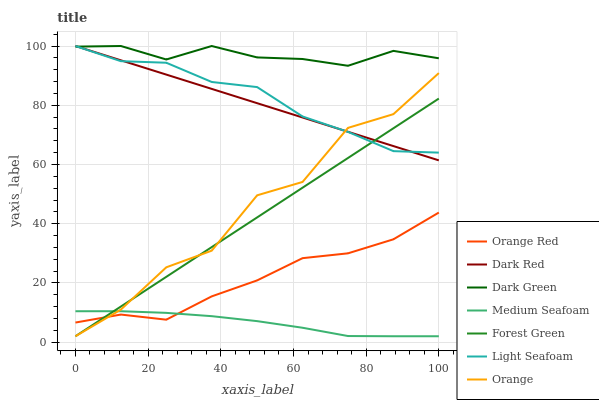Does Medium Seafoam have the minimum area under the curve?
Answer yes or no. Yes. Does Dark Green have the maximum area under the curve?
Answer yes or no. Yes. Does Orange Red have the minimum area under the curve?
Answer yes or no. No. Does Orange Red have the maximum area under the curve?
Answer yes or no. No. Is Dark Red the smoothest?
Answer yes or no. Yes. Is Orange the roughest?
Answer yes or no. Yes. Is Orange Red the smoothest?
Answer yes or no. No. Is Orange Red the roughest?
Answer yes or no. No. Does Forest Green have the lowest value?
Answer yes or no. Yes. Does Orange Red have the lowest value?
Answer yes or no. No. Does Dark Green have the highest value?
Answer yes or no. Yes. Does Orange Red have the highest value?
Answer yes or no. No. Is Medium Seafoam less than Dark Red?
Answer yes or no. Yes. Is Dark Red greater than Orange Red?
Answer yes or no. Yes. Does Orange intersect Light Seafoam?
Answer yes or no. Yes. Is Orange less than Light Seafoam?
Answer yes or no. No. Is Orange greater than Light Seafoam?
Answer yes or no. No. Does Medium Seafoam intersect Dark Red?
Answer yes or no. No. 